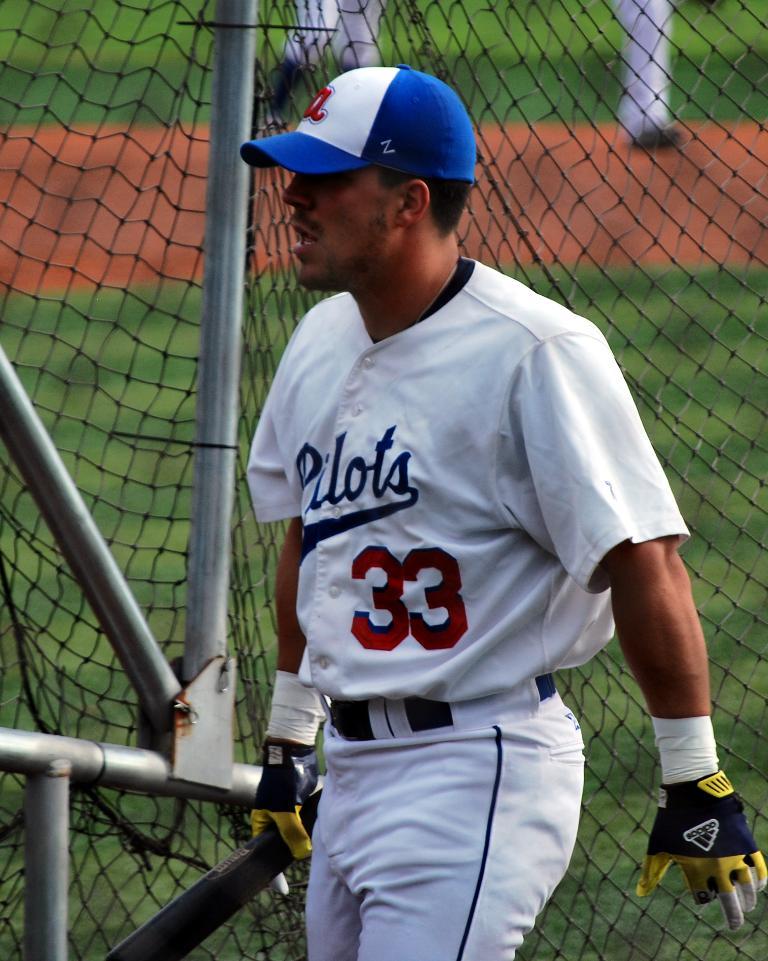What kind of gloves is he wearing?
Provide a short and direct response. Adidas. What number is the player?
Ensure brevity in your answer.  33. 